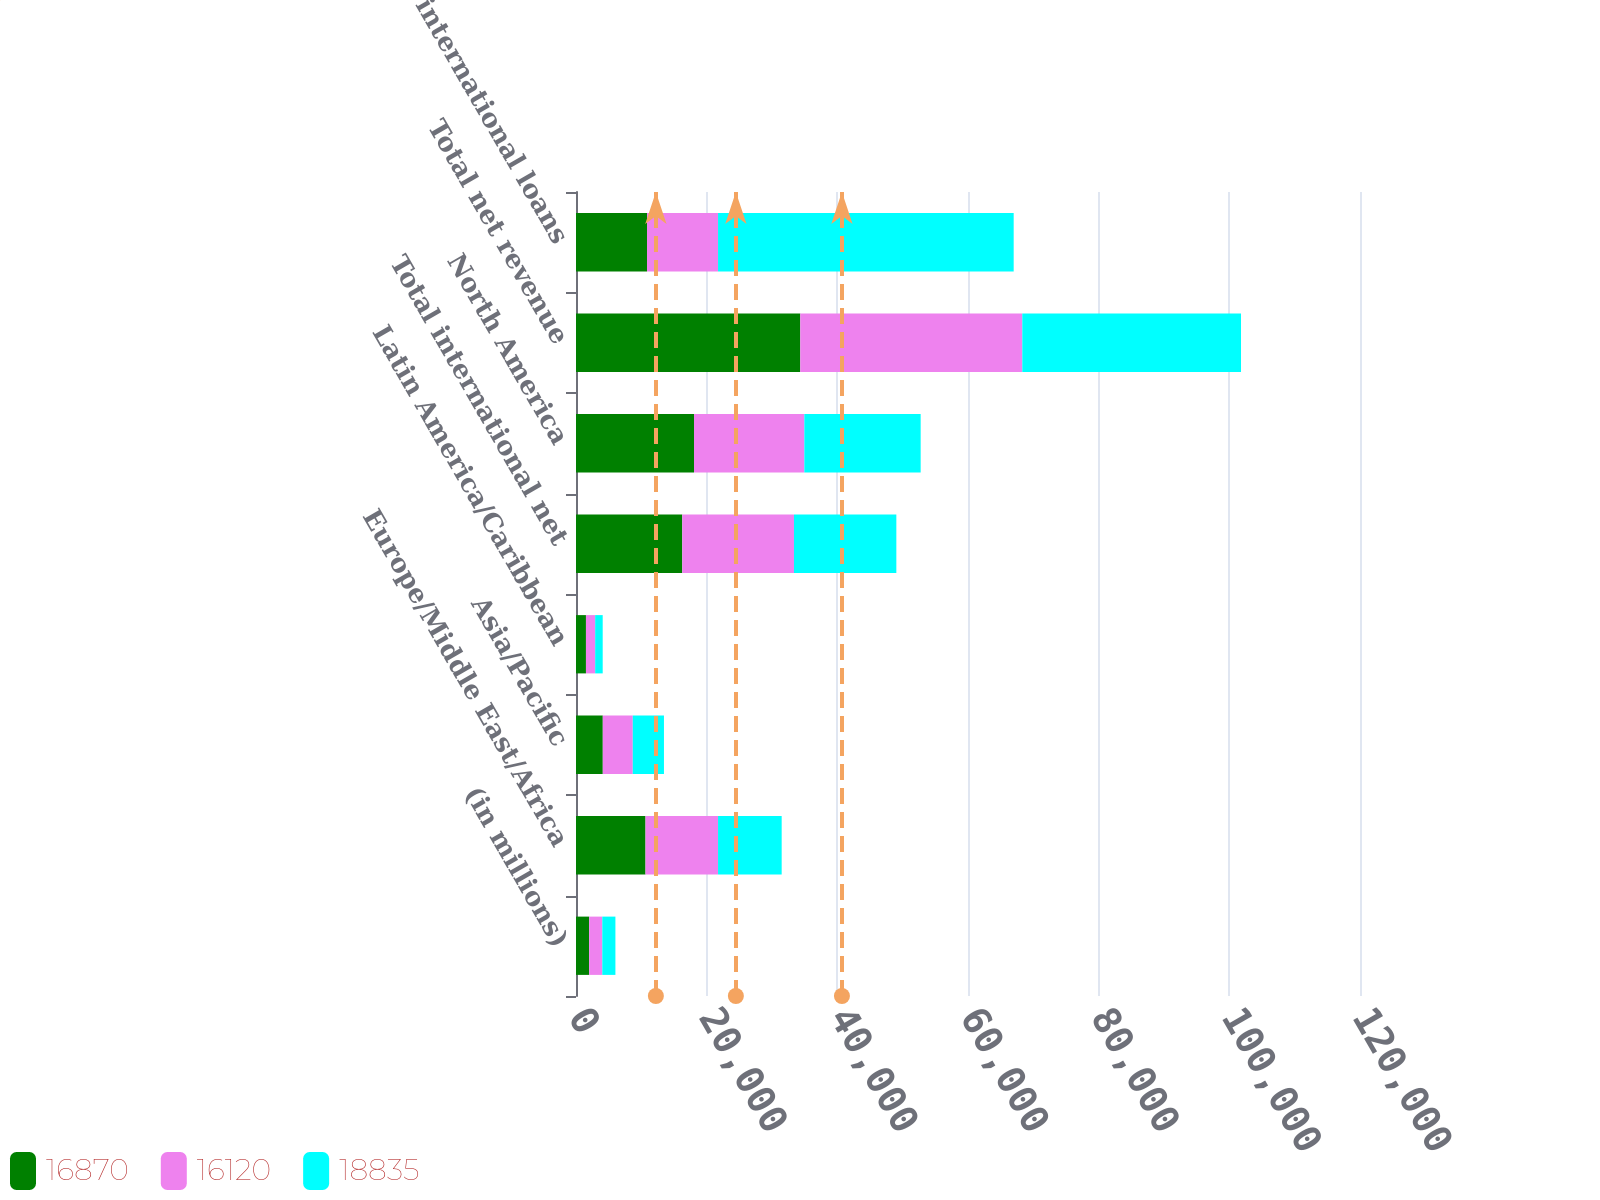Convert chart. <chart><loc_0><loc_0><loc_500><loc_500><stacked_bar_chart><ecel><fcel>(in millions)<fcel>Europe/Middle East/Africa<fcel>Asia/Pacific<fcel>Latin America/Caribbean<fcel>Total international net<fcel>North America<fcel>Total net revenue<fcel>Total international loans<nl><fcel>16870<fcel>2012<fcel>10639<fcel>4100<fcel>1524<fcel>16263<fcel>18063<fcel>34326<fcel>10870.5<nl><fcel>16120<fcel>2011<fcel>11102<fcel>4589<fcel>1409<fcel>17100<fcel>16884<fcel>33984<fcel>10870.5<nl><fcel>18835<fcel>2010<fcel>9740<fcel>4775<fcel>1154<fcel>15669<fcel>17808<fcel>33477<fcel>45251<nl></chart> 